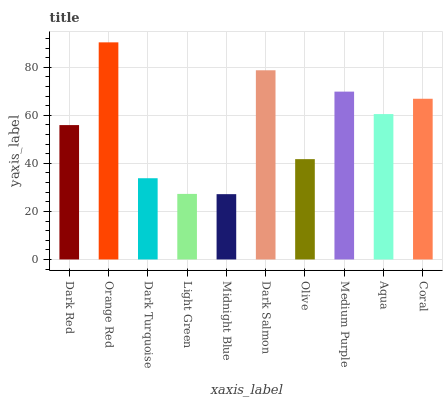Is Midnight Blue the minimum?
Answer yes or no. Yes. Is Orange Red the maximum?
Answer yes or no. Yes. Is Dark Turquoise the minimum?
Answer yes or no. No. Is Dark Turquoise the maximum?
Answer yes or no. No. Is Orange Red greater than Dark Turquoise?
Answer yes or no. Yes. Is Dark Turquoise less than Orange Red?
Answer yes or no. Yes. Is Dark Turquoise greater than Orange Red?
Answer yes or no. No. Is Orange Red less than Dark Turquoise?
Answer yes or no. No. Is Aqua the high median?
Answer yes or no. Yes. Is Dark Red the low median?
Answer yes or no. Yes. Is Light Green the high median?
Answer yes or no. No. Is Light Green the low median?
Answer yes or no. No. 